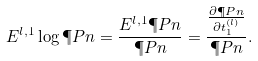Convert formula to latex. <formula><loc_0><loc_0><loc_500><loc_500>E ^ { l , 1 } \log \P P n = \frac { E ^ { l , 1 } \P P n } { \P P n } = \frac { \frac { \partial \P P n } { \partial t ^ { ( l ) } _ { 1 } } } { \P P n } .</formula> 